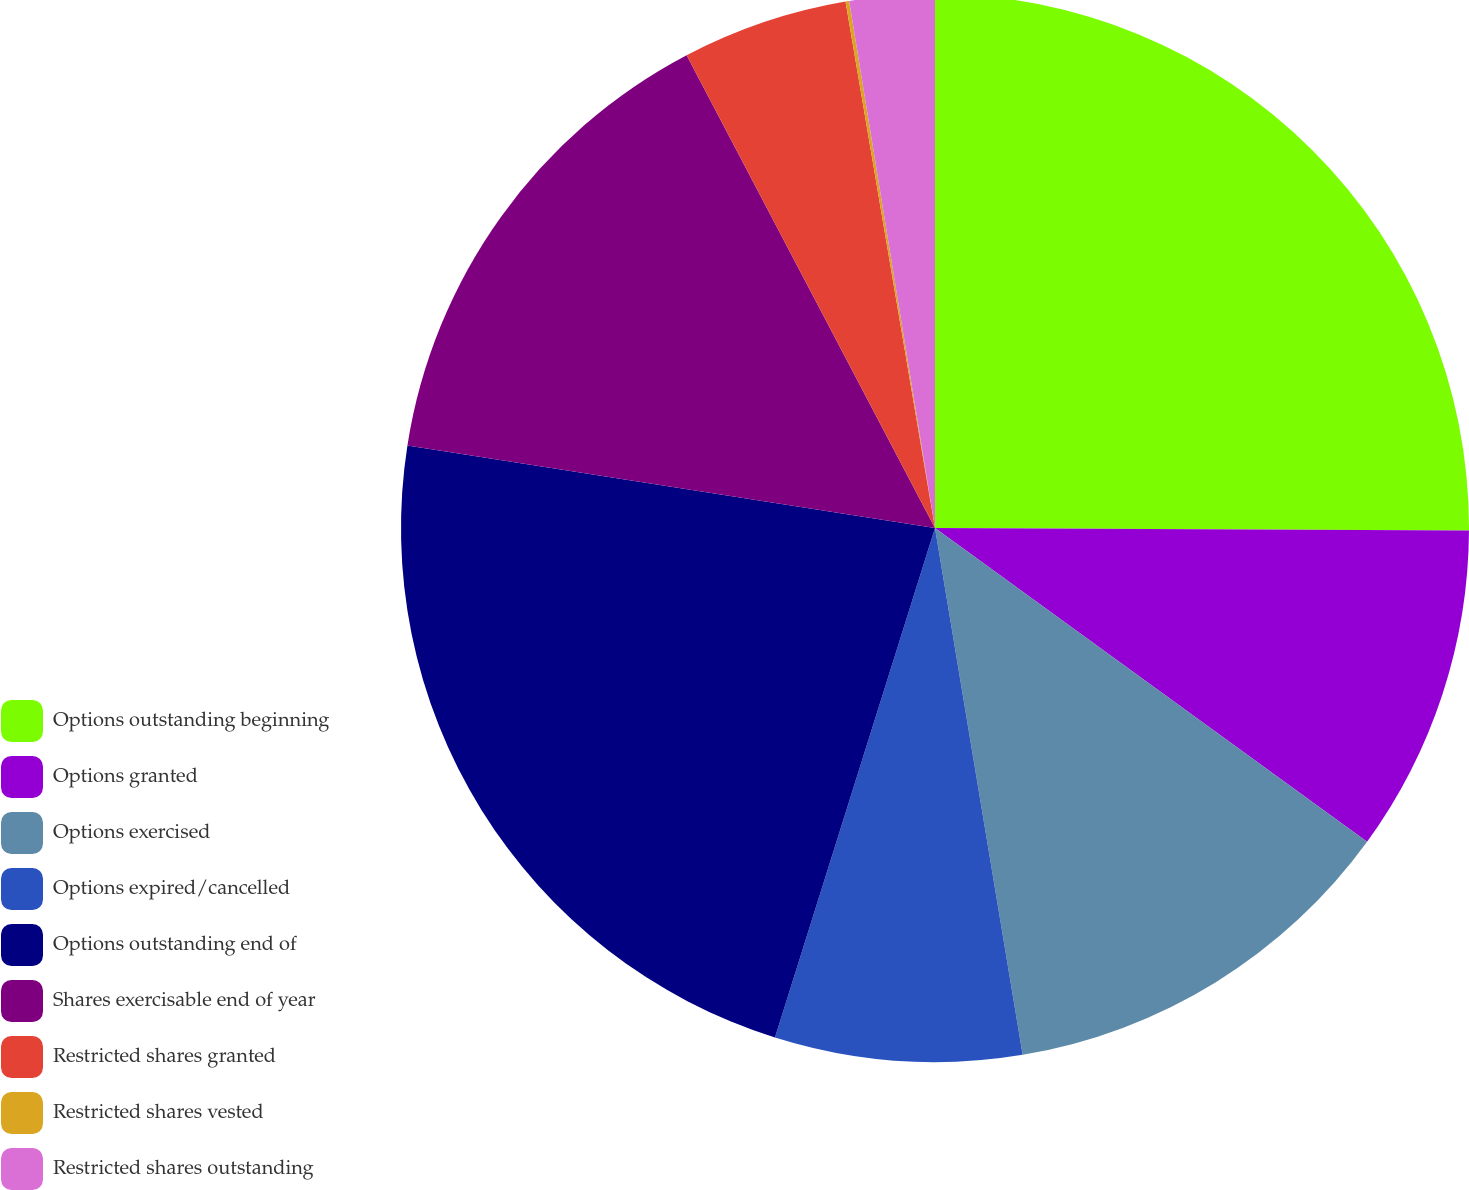Convert chart. <chart><loc_0><loc_0><loc_500><loc_500><pie_chart><fcel>Options outstanding beginning<fcel>Options granted<fcel>Options exercised<fcel>Options expired/cancelled<fcel>Options outstanding end of<fcel>Shares exercisable end of year<fcel>Restricted shares granted<fcel>Restricted shares vested<fcel>Restricted shares outstanding<nl><fcel>25.08%<fcel>9.92%<fcel>12.38%<fcel>7.47%<fcel>22.63%<fcel>14.83%<fcel>5.02%<fcel>0.11%<fcel>2.57%<nl></chart> 